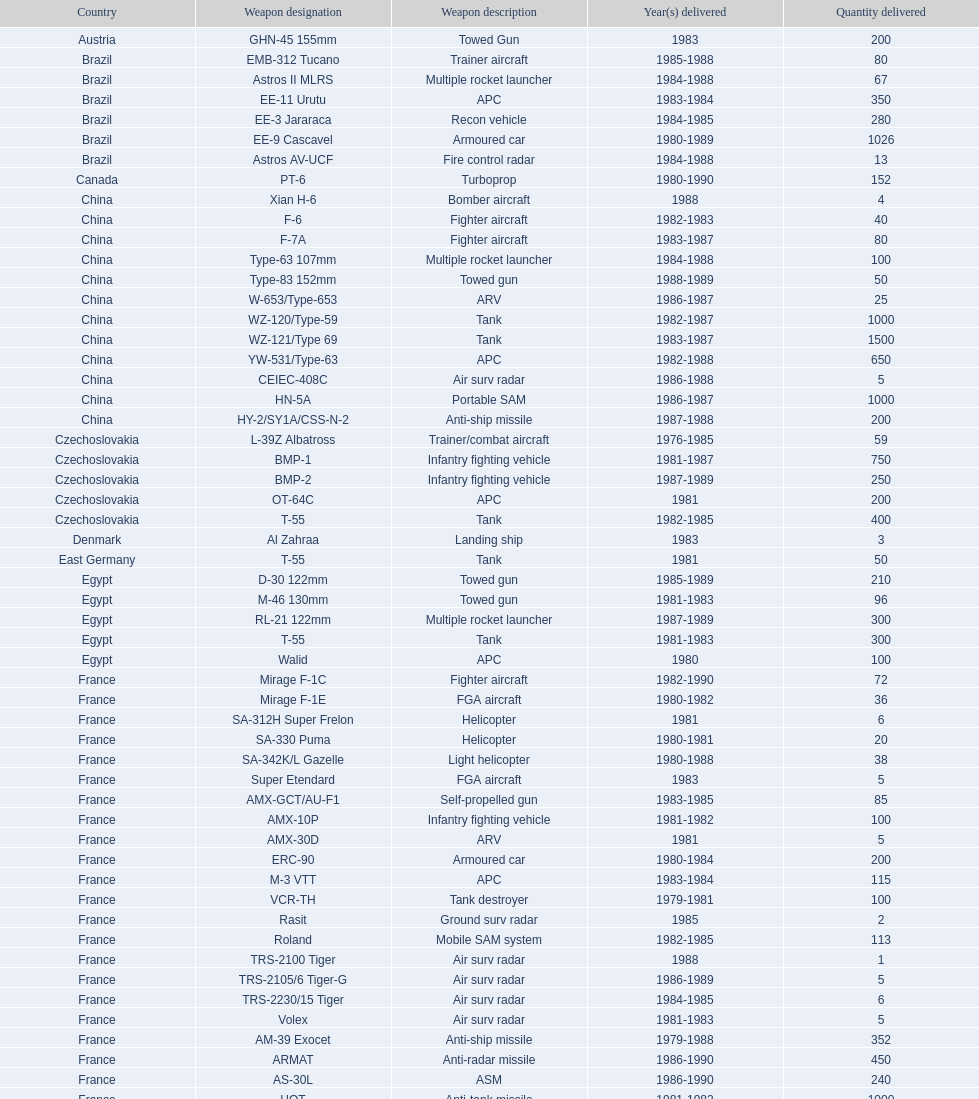According to this list, how many countries sold weapons to iraq? 21. 